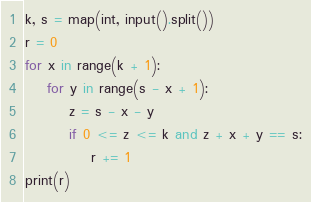Convert code to text. <code><loc_0><loc_0><loc_500><loc_500><_Python_>k, s = map(int, input().split())
r = 0
for x in range(k + 1):
    for y in range(s - x + 1):
        z = s - x - y
        if 0 <= z <= k and z + x + y == s:
            r += 1
print(r)
</code> 